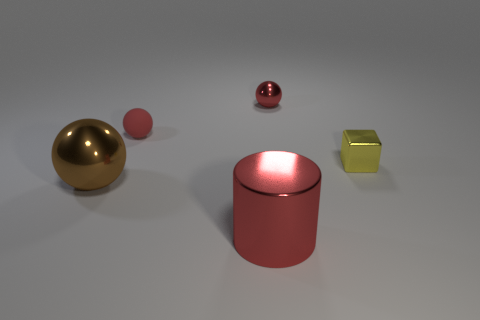There is another metallic thing that is the same shape as the big brown thing; what is its color? The smaller metallic object that shares the cylindrical shape with the larger brown one is colored a glossy red, similar to the hue of a cherry. 